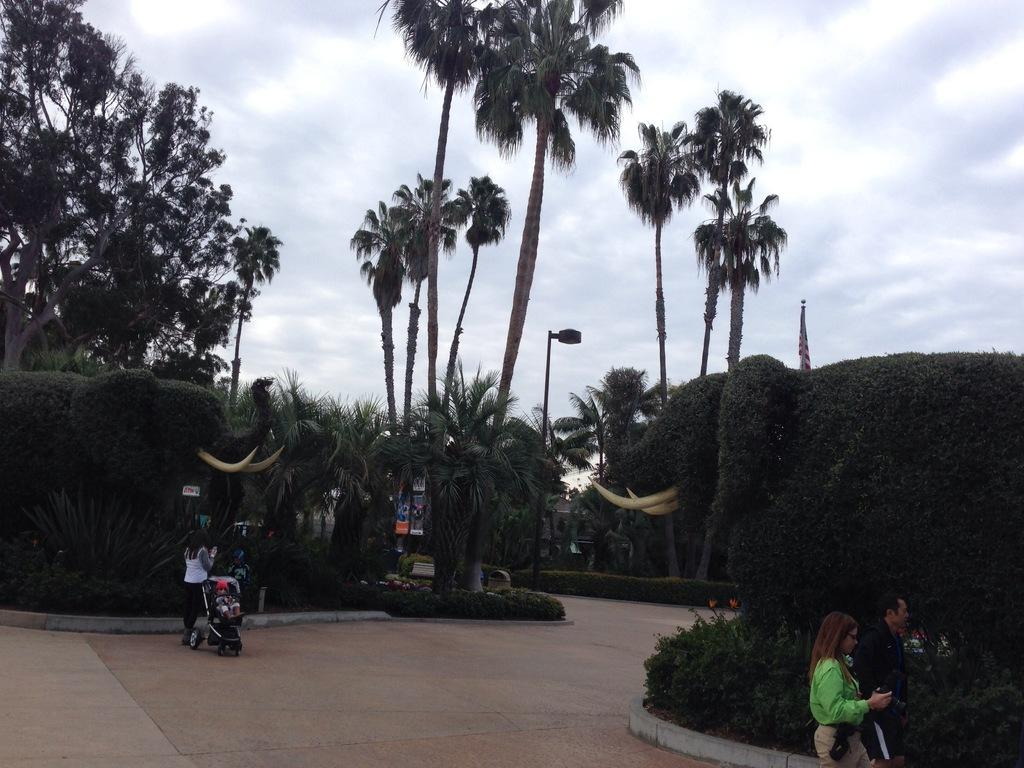What can be seen on the roads in the image? There are people on the roads in the image. What type of natural elements are visible in the image? There are trees visible in the image. What objects are present in the image that are not related to people or trees? There are boards and toys present in the image. Can you find a cactus in the image? There is no cactus present in the image. What type of locket is being worn by the people in the image? There is no locket visible in the image, as it does not mention any jewelry or accessories being worn by the people. 